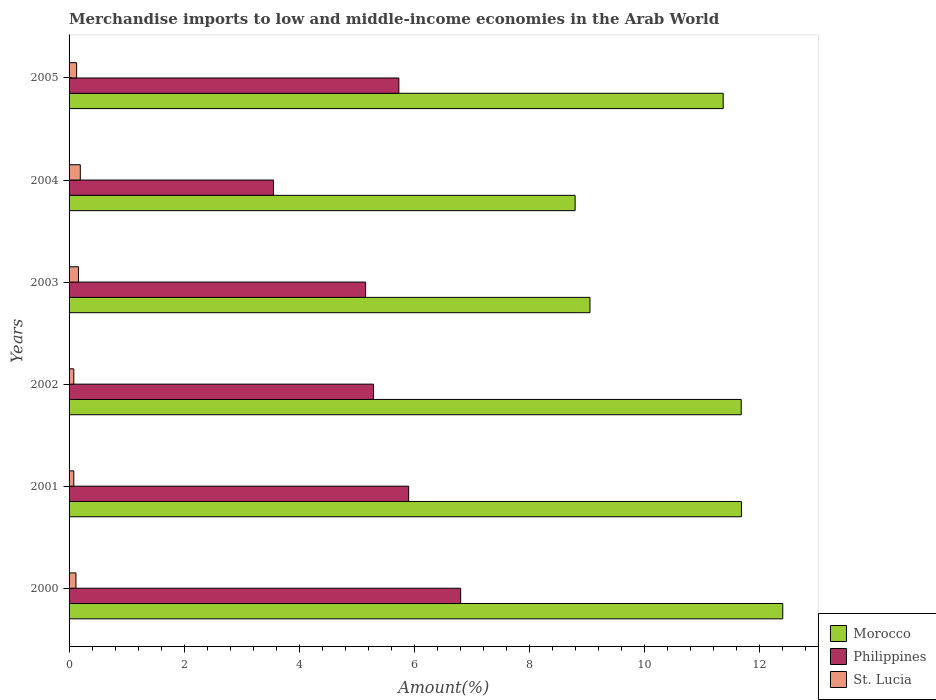How many different coloured bars are there?
Give a very brief answer. 3. Are the number of bars per tick equal to the number of legend labels?
Give a very brief answer. Yes. How many bars are there on the 5th tick from the bottom?
Provide a succinct answer. 3. What is the label of the 5th group of bars from the top?
Offer a very short reply. 2001. What is the percentage of amount earned from merchandise imports in Morocco in 2003?
Make the answer very short. 9.06. Across all years, what is the maximum percentage of amount earned from merchandise imports in St. Lucia?
Provide a short and direct response. 0.2. Across all years, what is the minimum percentage of amount earned from merchandise imports in St. Lucia?
Give a very brief answer. 0.08. In which year was the percentage of amount earned from merchandise imports in St. Lucia maximum?
Ensure brevity in your answer.  2004. What is the total percentage of amount earned from merchandise imports in Morocco in the graph?
Offer a very short reply. 65.03. What is the difference between the percentage of amount earned from merchandise imports in Morocco in 2001 and that in 2002?
Give a very brief answer. 0. What is the difference between the percentage of amount earned from merchandise imports in Philippines in 2003 and the percentage of amount earned from merchandise imports in Morocco in 2002?
Give a very brief answer. -6.53. What is the average percentage of amount earned from merchandise imports in Morocco per year?
Give a very brief answer. 10.84. In the year 2001, what is the difference between the percentage of amount earned from merchandise imports in Philippines and percentage of amount earned from merchandise imports in St. Lucia?
Your answer should be compact. 5.82. What is the ratio of the percentage of amount earned from merchandise imports in Morocco in 2001 to that in 2004?
Provide a succinct answer. 1.33. Is the percentage of amount earned from merchandise imports in Philippines in 2003 less than that in 2005?
Make the answer very short. Yes. What is the difference between the highest and the second highest percentage of amount earned from merchandise imports in St. Lucia?
Provide a succinct answer. 0.03. What is the difference between the highest and the lowest percentage of amount earned from merchandise imports in Philippines?
Provide a succinct answer. 3.25. In how many years, is the percentage of amount earned from merchandise imports in Philippines greater than the average percentage of amount earned from merchandise imports in Philippines taken over all years?
Offer a terse response. 3. Is the sum of the percentage of amount earned from merchandise imports in St. Lucia in 2003 and 2005 greater than the maximum percentage of amount earned from merchandise imports in Philippines across all years?
Your answer should be very brief. No. What does the 1st bar from the top in 2003 represents?
Keep it short and to the point. St. Lucia. What does the 2nd bar from the bottom in 2005 represents?
Make the answer very short. Philippines. How many bars are there?
Ensure brevity in your answer.  18. Are the values on the major ticks of X-axis written in scientific E-notation?
Offer a very short reply. No. Where does the legend appear in the graph?
Your answer should be very brief. Bottom right. What is the title of the graph?
Ensure brevity in your answer.  Merchandise imports to low and middle-income economies in the Arab World. What is the label or title of the X-axis?
Provide a succinct answer. Amount(%). What is the label or title of the Y-axis?
Offer a very short reply. Years. What is the Amount(%) of Morocco in 2000?
Offer a very short reply. 12.41. What is the Amount(%) in Philippines in 2000?
Offer a terse response. 6.81. What is the Amount(%) of St. Lucia in 2000?
Your answer should be compact. 0.12. What is the Amount(%) of Morocco in 2001?
Your answer should be compact. 11.69. What is the Amount(%) of Philippines in 2001?
Keep it short and to the point. 5.91. What is the Amount(%) in St. Lucia in 2001?
Your answer should be compact. 0.08. What is the Amount(%) in Morocco in 2002?
Ensure brevity in your answer.  11.69. What is the Amount(%) of Philippines in 2002?
Provide a short and direct response. 5.29. What is the Amount(%) in St. Lucia in 2002?
Ensure brevity in your answer.  0.08. What is the Amount(%) in Morocco in 2003?
Your response must be concise. 9.06. What is the Amount(%) in Philippines in 2003?
Offer a terse response. 5.16. What is the Amount(%) of St. Lucia in 2003?
Offer a terse response. 0.16. What is the Amount(%) in Morocco in 2004?
Keep it short and to the point. 8.8. What is the Amount(%) in Philippines in 2004?
Make the answer very short. 3.56. What is the Amount(%) of St. Lucia in 2004?
Ensure brevity in your answer.  0.2. What is the Amount(%) in Morocco in 2005?
Keep it short and to the point. 11.38. What is the Amount(%) of Philippines in 2005?
Keep it short and to the point. 5.74. What is the Amount(%) in St. Lucia in 2005?
Give a very brief answer. 0.13. Across all years, what is the maximum Amount(%) of Morocco?
Your answer should be very brief. 12.41. Across all years, what is the maximum Amount(%) in Philippines?
Make the answer very short. 6.81. Across all years, what is the maximum Amount(%) of St. Lucia?
Offer a very short reply. 0.2. Across all years, what is the minimum Amount(%) of Morocco?
Ensure brevity in your answer.  8.8. Across all years, what is the minimum Amount(%) of Philippines?
Ensure brevity in your answer.  3.56. Across all years, what is the minimum Amount(%) of St. Lucia?
Provide a succinct answer. 0.08. What is the total Amount(%) of Morocco in the graph?
Your response must be concise. 65.03. What is the total Amount(%) in Philippines in the graph?
Your answer should be very brief. 32.46. What is the total Amount(%) of St. Lucia in the graph?
Your answer should be compact. 0.78. What is the difference between the Amount(%) of Morocco in 2000 and that in 2001?
Your answer should be very brief. 0.72. What is the difference between the Amount(%) in Philippines in 2000 and that in 2001?
Offer a terse response. 0.9. What is the difference between the Amount(%) of St. Lucia in 2000 and that in 2001?
Your response must be concise. 0.04. What is the difference between the Amount(%) in Morocco in 2000 and that in 2002?
Keep it short and to the point. 0.72. What is the difference between the Amount(%) of Philippines in 2000 and that in 2002?
Provide a short and direct response. 1.52. What is the difference between the Amount(%) of St. Lucia in 2000 and that in 2002?
Offer a very short reply. 0.04. What is the difference between the Amount(%) of Morocco in 2000 and that in 2003?
Make the answer very short. 3.35. What is the difference between the Amount(%) in Philippines in 2000 and that in 2003?
Your answer should be very brief. 1.65. What is the difference between the Amount(%) in St. Lucia in 2000 and that in 2003?
Keep it short and to the point. -0.04. What is the difference between the Amount(%) in Morocco in 2000 and that in 2004?
Offer a very short reply. 3.61. What is the difference between the Amount(%) in Philippines in 2000 and that in 2004?
Your answer should be very brief. 3.25. What is the difference between the Amount(%) of St. Lucia in 2000 and that in 2004?
Offer a very short reply. -0.08. What is the difference between the Amount(%) of Morocco in 2000 and that in 2005?
Your answer should be very brief. 1.04. What is the difference between the Amount(%) of Philippines in 2000 and that in 2005?
Keep it short and to the point. 1.07. What is the difference between the Amount(%) of St. Lucia in 2000 and that in 2005?
Provide a short and direct response. -0.01. What is the difference between the Amount(%) of Morocco in 2001 and that in 2002?
Offer a very short reply. 0. What is the difference between the Amount(%) in Philippines in 2001 and that in 2002?
Offer a very short reply. 0.61. What is the difference between the Amount(%) in St. Lucia in 2001 and that in 2002?
Offer a terse response. -0. What is the difference between the Amount(%) of Morocco in 2001 and that in 2003?
Your response must be concise. 2.63. What is the difference between the Amount(%) of Philippines in 2001 and that in 2003?
Keep it short and to the point. 0.75. What is the difference between the Amount(%) of St. Lucia in 2001 and that in 2003?
Give a very brief answer. -0.08. What is the difference between the Amount(%) of Morocco in 2001 and that in 2004?
Your answer should be very brief. 2.89. What is the difference between the Amount(%) in Philippines in 2001 and that in 2004?
Your answer should be very brief. 2.35. What is the difference between the Amount(%) in St. Lucia in 2001 and that in 2004?
Your response must be concise. -0.11. What is the difference between the Amount(%) in Morocco in 2001 and that in 2005?
Your answer should be very brief. 0.32. What is the difference between the Amount(%) in Philippines in 2001 and that in 2005?
Provide a succinct answer. 0.17. What is the difference between the Amount(%) in St. Lucia in 2001 and that in 2005?
Keep it short and to the point. -0.05. What is the difference between the Amount(%) of Morocco in 2002 and that in 2003?
Keep it short and to the point. 2.63. What is the difference between the Amount(%) of Philippines in 2002 and that in 2003?
Make the answer very short. 0.14. What is the difference between the Amount(%) of St. Lucia in 2002 and that in 2003?
Ensure brevity in your answer.  -0.08. What is the difference between the Amount(%) of Morocco in 2002 and that in 2004?
Offer a very short reply. 2.89. What is the difference between the Amount(%) of Philippines in 2002 and that in 2004?
Your answer should be compact. 1.74. What is the difference between the Amount(%) of St. Lucia in 2002 and that in 2004?
Provide a short and direct response. -0.11. What is the difference between the Amount(%) in Morocco in 2002 and that in 2005?
Give a very brief answer. 0.31. What is the difference between the Amount(%) in Philippines in 2002 and that in 2005?
Your answer should be very brief. -0.44. What is the difference between the Amount(%) in St. Lucia in 2002 and that in 2005?
Offer a terse response. -0.05. What is the difference between the Amount(%) of Morocco in 2003 and that in 2004?
Provide a short and direct response. 0.26. What is the difference between the Amount(%) of Philippines in 2003 and that in 2004?
Provide a succinct answer. 1.6. What is the difference between the Amount(%) in St. Lucia in 2003 and that in 2004?
Ensure brevity in your answer.  -0.03. What is the difference between the Amount(%) of Morocco in 2003 and that in 2005?
Your response must be concise. -2.32. What is the difference between the Amount(%) in Philippines in 2003 and that in 2005?
Keep it short and to the point. -0.58. What is the difference between the Amount(%) in St. Lucia in 2003 and that in 2005?
Your answer should be compact. 0.03. What is the difference between the Amount(%) of Morocco in 2004 and that in 2005?
Offer a very short reply. -2.57. What is the difference between the Amount(%) of Philippines in 2004 and that in 2005?
Your answer should be compact. -2.18. What is the difference between the Amount(%) of St. Lucia in 2004 and that in 2005?
Your answer should be very brief. 0.06. What is the difference between the Amount(%) of Morocco in 2000 and the Amount(%) of Philippines in 2001?
Your answer should be compact. 6.51. What is the difference between the Amount(%) in Morocco in 2000 and the Amount(%) in St. Lucia in 2001?
Offer a terse response. 12.33. What is the difference between the Amount(%) in Philippines in 2000 and the Amount(%) in St. Lucia in 2001?
Offer a very short reply. 6.73. What is the difference between the Amount(%) of Morocco in 2000 and the Amount(%) of Philippines in 2002?
Your answer should be very brief. 7.12. What is the difference between the Amount(%) of Morocco in 2000 and the Amount(%) of St. Lucia in 2002?
Provide a succinct answer. 12.33. What is the difference between the Amount(%) in Philippines in 2000 and the Amount(%) in St. Lucia in 2002?
Keep it short and to the point. 6.73. What is the difference between the Amount(%) in Morocco in 2000 and the Amount(%) in Philippines in 2003?
Offer a very short reply. 7.25. What is the difference between the Amount(%) in Morocco in 2000 and the Amount(%) in St. Lucia in 2003?
Make the answer very short. 12.25. What is the difference between the Amount(%) of Philippines in 2000 and the Amount(%) of St. Lucia in 2003?
Provide a succinct answer. 6.65. What is the difference between the Amount(%) of Morocco in 2000 and the Amount(%) of Philippines in 2004?
Offer a very short reply. 8.86. What is the difference between the Amount(%) in Morocco in 2000 and the Amount(%) in St. Lucia in 2004?
Your answer should be very brief. 12.22. What is the difference between the Amount(%) in Philippines in 2000 and the Amount(%) in St. Lucia in 2004?
Your response must be concise. 6.61. What is the difference between the Amount(%) of Morocco in 2000 and the Amount(%) of Philippines in 2005?
Give a very brief answer. 6.68. What is the difference between the Amount(%) of Morocco in 2000 and the Amount(%) of St. Lucia in 2005?
Provide a succinct answer. 12.28. What is the difference between the Amount(%) of Philippines in 2000 and the Amount(%) of St. Lucia in 2005?
Your answer should be very brief. 6.68. What is the difference between the Amount(%) of Morocco in 2001 and the Amount(%) of Philippines in 2002?
Keep it short and to the point. 6.4. What is the difference between the Amount(%) of Morocco in 2001 and the Amount(%) of St. Lucia in 2002?
Provide a short and direct response. 11.61. What is the difference between the Amount(%) of Philippines in 2001 and the Amount(%) of St. Lucia in 2002?
Make the answer very short. 5.82. What is the difference between the Amount(%) of Morocco in 2001 and the Amount(%) of Philippines in 2003?
Make the answer very short. 6.54. What is the difference between the Amount(%) of Morocco in 2001 and the Amount(%) of St. Lucia in 2003?
Provide a succinct answer. 11.53. What is the difference between the Amount(%) in Philippines in 2001 and the Amount(%) in St. Lucia in 2003?
Give a very brief answer. 5.74. What is the difference between the Amount(%) in Morocco in 2001 and the Amount(%) in Philippines in 2004?
Provide a succinct answer. 8.14. What is the difference between the Amount(%) of Morocco in 2001 and the Amount(%) of St. Lucia in 2004?
Ensure brevity in your answer.  11.5. What is the difference between the Amount(%) in Philippines in 2001 and the Amount(%) in St. Lucia in 2004?
Offer a terse response. 5.71. What is the difference between the Amount(%) of Morocco in 2001 and the Amount(%) of Philippines in 2005?
Ensure brevity in your answer.  5.96. What is the difference between the Amount(%) of Morocco in 2001 and the Amount(%) of St. Lucia in 2005?
Your answer should be very brief. 11.56. What is the difference between the Amount(%) in Philippines in 2001 and the Amount(%) in St. Lucia in 2005?
Your response must be concise. 5.77. What is the difference between the Amount(%) of Morocco in 2002 and the Amount(%) of Philippines in 2003?
Offer a terse response. 6.53. What is the difference between the Amount(%) in Morocco in 2002 and the Amount(%) in St. Lucia in 2003?
Your answer should be compact. 11.53. What is the difference between the Amount(%) in Philippines in 2002 and the Amount(%) in St. Lucia in 2003?
Give a very brief answer. 5.13. What is the difference between the Amount(%) in Morocco in 2002 and the Amount(%) in Philippines in 2004?
Your response must be concise. 8.13. What is the difference between the Amount(%) in Morocco in 2002 and the Amount(%) in St. Lucia in 2004?
Provide a short and direct response. 11.49. What is the difference between the Amount(%) of Philippines in 2002 and the Amount(%) of St. Lucia in 2004?
Offer a very short reply. 5.1. What is the difference between the Amount(%) of Morocco in 2002 and the Amount(%) of Philippines in 2005?
Offer a very short reply. 5.95. What is the difference between the Amount(%) in Morocco in 2002 and the Amount(%) in St. Lucia in 2005?
Ensure brevity in your answer.  11.56. What is the difference between the Amount(%) in Philippines in 2002 and the Amount(%) in St. Lucia in 2005?
Your answer should be very brief. 5.16. What is the difference between the Amount(%) of Morocco in 2003 and the Amount(%) of Philippines in 2004?
Keep it short and to the point. 5.5. What is the difference between the Amount(%) of Morocco in 2003 and the Amount(%) of St. Lucia in 2004?
Your response must be concise. 8.86. What is the difference between the Amount(%) in Philippines in 2003 and the Amount(%) in St. Lucia in 2004?
Offer a terse response. 4.96. What is the difference between the Amount(%) of Morocco in 2003 and the Amount(%) of Philippines in 2005?
Provide a succinct answer. 3.32. What is the difference between the Amount(%) in Morocco in 2003 and the Amount(%) in St. Lucia in 2005?
Your answer should be very brief. 8.93. What is the difference between the Amount(%) of Philippines in 2003 and the Amount(%) of St. Lucia in 2005?
Offer a terse response. 5.03. What is the difference between the Amount(%) in Morocco in 2004 and the Amount(%) in Philippines in 2005?
Your answer should be very brief. 3.07. What is the difference between the Amount(%) of Morocco in 2004 and the Amount(%) of St. Lucia in 2005?
Your answer should be very brief. 8.67. What is the difference between the Amount(%) of Philippines in 2004 and the Amount(%) of St. Lucia in 2005?
Give a very brief answer. 3.42. What is the average Amount(%) in Morocco per year?
Offer a very short reply. 10.84. What is the average Amount(%) in Philippines per year?
Make the answer very short. 5.41. What is the average Amount(%) of St. Lucia per year?
Give a very brief answer. 0.13. In the year 2000, what is the difference between the Amount(%) in Morocco and Amount(%) in Philippines?
Provide a short and direct response. 5.6. In the year 2000, what is the difference between the Amount(%) in Morocco and Amount(%) in St. Lucia?
Your answer should be compact. 12.29. In the year 2000, what is the difference between the Amount(%) in Philippines and Amount(%) in St. Lucia?
Make the answer very short. 6.69. In the year 2001, what is the difference between the Amount(%) of Morocco and Amount(%) of Philippines?
Your response must be concise. 5.79. In the year 2001, what is the difference between the Amount(%) of Morocco and Amount(%) of St. Lucia?
Keep it short and to the point. 11.61. In the year 2001, what is the difference between the Amount(%) in Philippines and Amount(%) in St. Lucia?
Make the answer very short. 5.82. In the year 2002, what is the difference between the Amount(%) of Morocco and Amount(%) of Philippines?
Your answer should be very brief. 6.4. In the year 2002, what is the difference between the Amount(%) of Morocco and Amount(%) of St. Lucia?
Offer a very short reply. 11.61. In the year 2002, what is the difference between the Amount(%) of Philippines and Amount(%) of St. Lucia?
Make the answer very short. 5.21. In the year 2003, what is the difference between the Amount(%) of Morocco and Amount(%) of Philippines?
Ensure brevity in your answer.  3.9. In the year 2003, what is the difference between the Amount(%) of Morocco and Amount(%) of St. Lucia?
Offer a very short reply. 8.9. In the year 2003, what is the difference between the Amount(%) of Philippines and Amount(%) of St. Lucia?
Your answer should be compact. 4.99. In the year 2004, what is the difference between the Amount(%) in Morocco and Amount(%) in Philippines?
Provide a short and direct response. 5.25. In the year 2004, what is the difference between the Amount(%) of Morocco and Amount(%) of St. Lucia?
Your response must be concise. 8.61. In the year 2004, what is the difference between the Amount(%) in Philippines and Amount(%) in St. Lucia?
Keep it short and to the point. 3.36. In the year 2005, what is the difference between the Amount(%) of Morocco and Amount(%) of Philippines?
Make the answer very short. 5.64. In the year 2005, what is the difference between the Amount(%) of Morocco and Amount(%) of St. Lucia?
Your answer should be compact. 11.24. In the year 2005, what is the difference between the Amount(%) in Philippines and Amount(%) in St. Lucia?
Your answer should be very brief. 5.6. What is the ratio of the Amount(%) in Morocco in 2000 to that in 2001?
Provide a short and direct response. 1.06. What is the ratio of the Amount(%) in Philippines in 2000 to that in 2001?
Give a very brief answer. 1.15. What is the ratio of the Amount(%) in St. Lucia in 2000 to that in 2001?
Offer a terse response. 1.46. What is the ratio of the Amount(%) of Morocco in 2000 to that in 2002?
Your answer should be very brief. 1.06. What is the ratio of the Amount(%) of Philippines in 2000 to that in 2002?
Keep it short and to the point. 1.29. What is the ratio of the Amount(%) in St. Lucia in 2000 to that in 2002?
Provide a short and direct response. 1.46. What is the ratio of the Amount(%) in Morocco in 2000 to that in 2003?
Provide a short and direct response. 1.37. What is the ratio of the Amount(%) of Philippines in 2000 to that in 2003?
Ensure brevity in your answer.  1.32. What is the ratio of the Amount(%) in St. Lucia in 2000 to that in 2003?
Offer a very short reply. 0.74. What is the ratio of the Amount(%) of Morocco in 2000 to that in 2004?
Ensure brevity in your answer.  1.41. What is the ratio of the Amount(%) in Philippines in 2000 to that in 2004?
Your answer should be very brief. 1.92. What is the ratio of the Amount(%) in St. Lucia in 2000 to that in 2004?
Provide a succinct answer. 0.61. What is the ratio of the Amount(%) of Morocco in 2000 to that in 2005?
Keep it short and to the point. 1.09. What is the ratio of the Amount(%) of Philippines in 2000 to that in 2005?
Provide a short and direct response. 1.19. What is the ratio of the Amount(%) in St. Lucia in 2000 to that in 2005?
Provide a succinct answer. 0.91. What is the ratio of the Amount(%) of Philippines in 2001 to that in 2002?
Provide a succinct answer. 1.12. What is the ratio of the Amount(%) in Morocco in 2001 to that in 2003?
Your answer should be compact. 1.29. What is the ratio of the Amount(%) in Philippines in 2001 to that in 2003?
Provide a short and direct response. 1.15. What is the ratio of the Amount(%) in St. Lucia in 2001 to that in 2003?
Make the answer very short. 0.51. What is the ratio of the Amount(%) in Morocco in 2001 to that in 2004?
Your response must be concise. 1.33. What is the ratio of the Amount(%) of Philippines in 2001 to that in 2004?
Your response must be concise. 1.66. What is the ratio of the Amount(%) of St. Lucia in 2001 to that in 2004?
Your answer should be compact. 0.42. What is the ratio of the Amount(%) of Morocco in 2001 to that in 2005?
Make the answer very short. 1.03. What is the ratio of the Amount(%) in Philippines in 2001 to that in 2005?
Your answer should be very brief. 1.03. What is the ratio of the Amount(%) in St. Lucia in 2001 to that in 2005?
Your answer should be very brief. 0.63. What is the ratio of the Amount(%) in Morocco in 2002 to that in 2003?
Provide a succinct answer. 1.29. What is the ratio of the Amount(%) in Philippines in 2002 to that in 2003?
Make the answer very short. 1.03. What is the ratio of the Amount(%) in St. Lucia in 2002 to that in 2003?
Offer a very short reply. 0.51. What is the ratio of the Amount(%) of Morocco in 2002 to that in 2004?
Give a very brief answer. 1.33. What is the ratio of the Amount(%) in Philippines in 2002 to that in 2004?
Make the answer very short. 1.49. What is the ratio of the Amount(%) of St. Lucia in 2002 to that in 2004?
Provide a succinct answer. 0.42. What is the ratio of the Amount(%) in Morocco in 2002 to that in 2005?
Your answer should be very brief. 1.03. What is the ratio of the Amount(%) of Philippines in 2002 to that in 2005?
Provide a short and direct response. 0.92. What is the ratio of the Amount(%) in St. Lucia in 2002 to that in 2005?
Your answer should be very brief. 0.63. What is the ratio of the Amount(%) in Morocco in 2003 to that in 2004?
Make the answer very short. 1.03. What is the ratio of the Amount(%) in Philippines in 2003 to that in 2004?
Offer a very short reply. 1.45. What is the ratio of the Amount(%) in St. Lucia in 2003 to that in 2004?
Make the answer very short. 0.83. What is the ratio of the Amount(%) in Morocco in 2003 to that in 2005?
Your answer should be very brief. 0.8. What is the ratio of the Amount(%) of Philippines in 2003 to that in 2005?
Offer a terse response. 0.9. What is the ratio of the Amount(%) in St. Lucia in 2003 to that in 2005?
Your answer should be very brief. 1.24. What is the ratio of the Amount(%) in Morocco in 2004 to that in 2005?
Give a very brief answer. 0.77. What is the ratio of the Amount(%) in Philippines in 2004 to that in 2005?
Your response must be concise. 0.62. What is the ratio of the Amount(%) of St. Lucia in 2004 to that in 2005?
Offer a terse response. 1.49. What is the difference between the highest and the second highest Amount(%) of Morocco?
Make the answer very short. 0.72. What is the difference between the highest and the second highest Amount(%) in Philippines?
Ensure brevity in your answer.  0.9. What is the difference between the highest and the second highest Amount(%) of St. Lucia?
Offer a terse response. 0.03. What is the difference between the highest and the lowest Amount(%) in Morocco?
Provide a succinct answer. 3.61. What is the difference between the highest and the lowest Amount(%) in Philippines?
Keep it short and to the point. 3.25. What is the difference between the highest and the lowest Amount(%) in St. Lucia?
Your answer should be very brief. 0.11. 